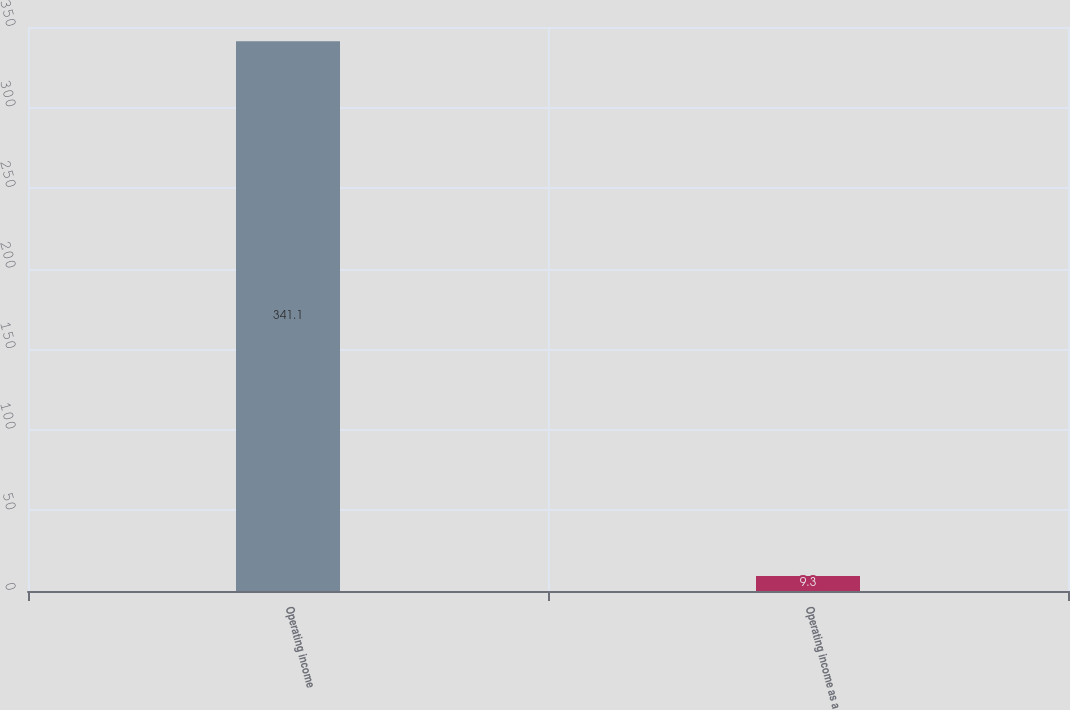<chart> <loc_0><loc_0><loc_500><loc_500><bar_chart><fcel>Operating income<fcel>Operating income as a<nl><fcel>341.1<fcel>9.3<nl></chart> 